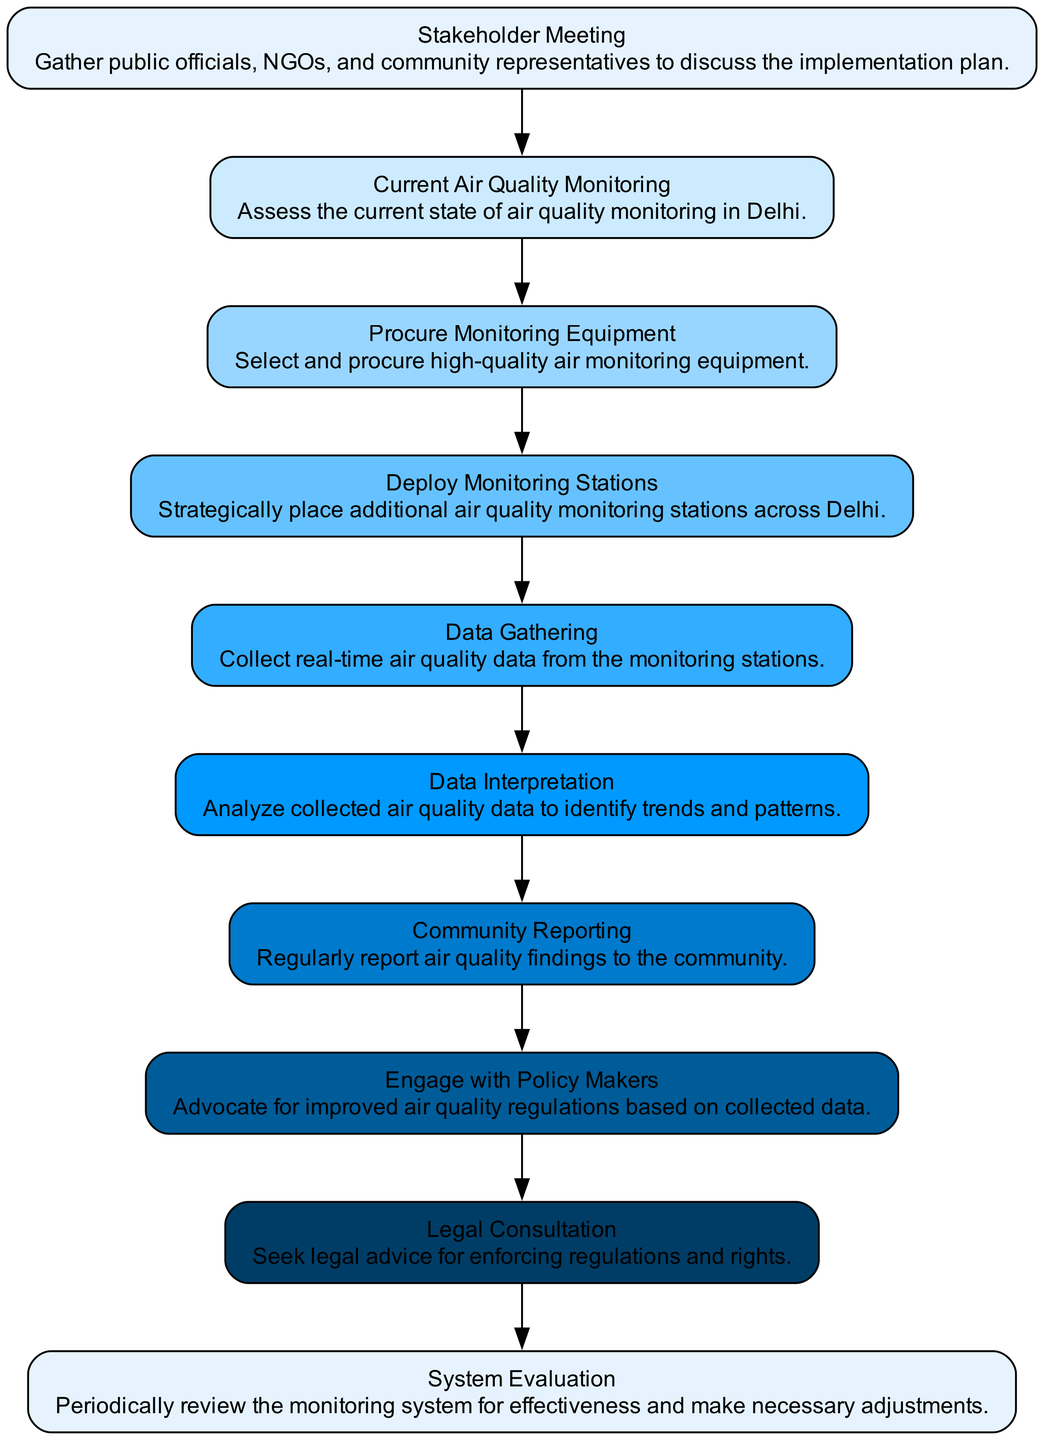What is the first step in the clinical pathway? The first step listed in the diagram is "Stakeholder Meeting," which initiates the process to gather involved parties.
Answer: Stakeholder Meeting How many pieces of equipment are selected in the Technology Selection phase? In the Technology Selection phase, three types of equipment are listed: PM2.5 and PM10 Sensors, NO2, SO2, and O3 Gas Analyzers, and Meteorological Instruments.
Answer: Three Which group is involved in the Legal Support phase? The Legal Support phase includes "Environmental Law Attorneys" and "Public Interest Litigation Experts" as advisors for legal consultation and support.
Answer: Environmental Law Attorneys, Public Interest Litigation Experts What is the frequency of Data Gathering? The diagram specifies that data gathering happens on a "Daily" basis, indicating how often air quality data should be collected from the monitoring stations.
Answer: Daily Which node advocates for regulations based on collected data? The node responsible for advocating for improved air quality regulations based on the collected data is "Engage with Policy Makers," which encompasses lobbying and campaigning activities.
Answer: Engage with Policy Makers In the Review and Adjustments phase, how often is the system evaluated? The "System Evaluation" phase mentions a "Bi-Annual" frequency for reviewing the monitoring system's effectiveness and making necessary adjustments.
Answer: Bi-Annual What are the channels used for community reporting? The "Community Reporting" node lists four channels: Mobile App, Website Dashboard, Local News Outlets, and Public Meetings, through which findings are shared with the community.
Answer: Mobile App, Website Dashboard, Local News Outlets, Public Meetings Which node involves placing air quality monitoring stations? The "Deploy Monitoring Stations" step is specifically focused on the action of strategically placing additional air quality monitoring stations across various sites in Delhi.
Answer: Deploy Monitoring Stations What is a method used in Baseline Assessment? One of the methods listed in the Baseline Assessment phase is "Review existing air quality data from Delhi Safe Air Monitoring System," which helps assess the current state of air quality monitoring.
Answer: Review existing air quality data from Delhi Safe Air Monitoring System 